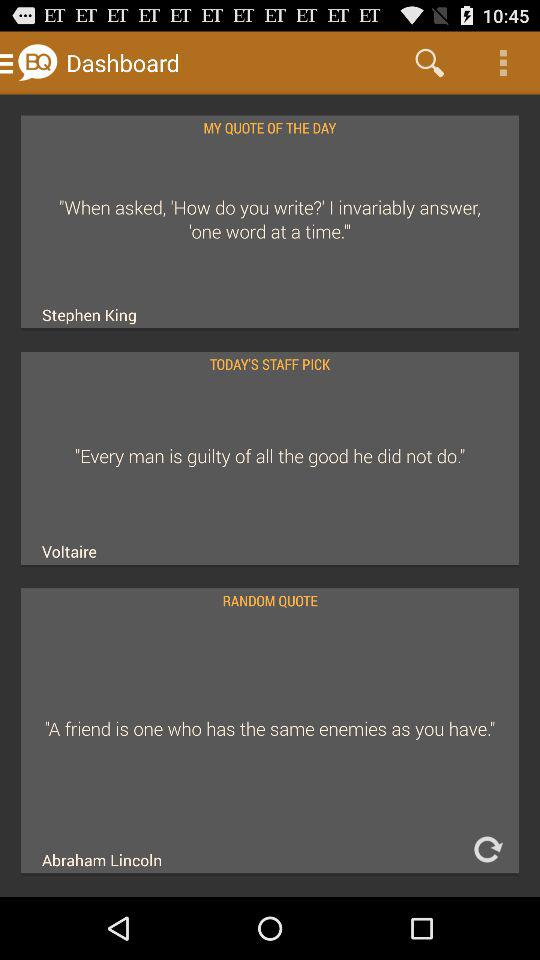What is the name of the application? The name of the application is "Brilliant Quotes". 